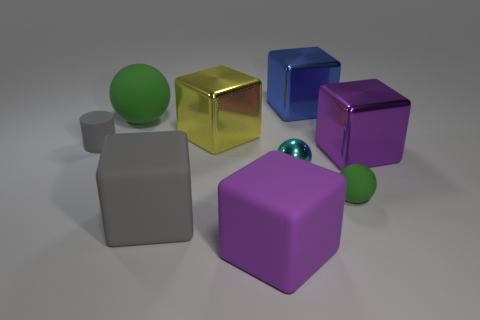Subtract all gray matte blocks. How many blocks are left? 4 Subtract 2 cubes. How many cubes are left? 3 Subtract all blue cubes. How many cubes are left? 4 Subtract all brown cubes. Subtract all red balls. How many cubes are left? 5 Add 1 small red shiny balls. How many objects exist? 10 Subtract all blocks. How many objects are left? 4 Add 6 big purple rubber blocks. How many big purple rubber blocks are left? 7 Add 1 big yellow shiny objects. How many big yellow shiny objects exist? 2 Subtract 1 gray cylinders. How many objects are left? 8 Subtract all cyan rubber cylinders. Subtract all big gray cubes. How many objects are left? 8 